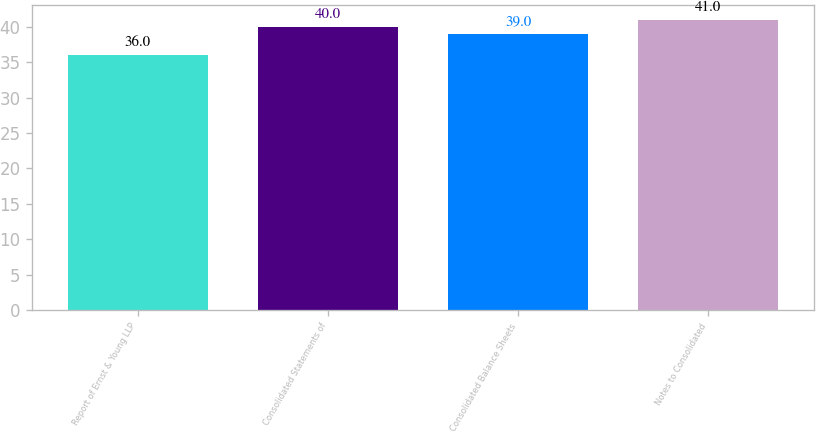<chart> <loc_0><loc_0><loc_500><loc_500><bar_chart><fcel>Report of Ernst & Young LLP<fcel>Consolidated Statements of<fcel>Consolidated Balance Sheets<fcel>Notes to Consolidated<nl><fcel>36<fcel>40<fcel>39<fcel>41<nl></chart> 